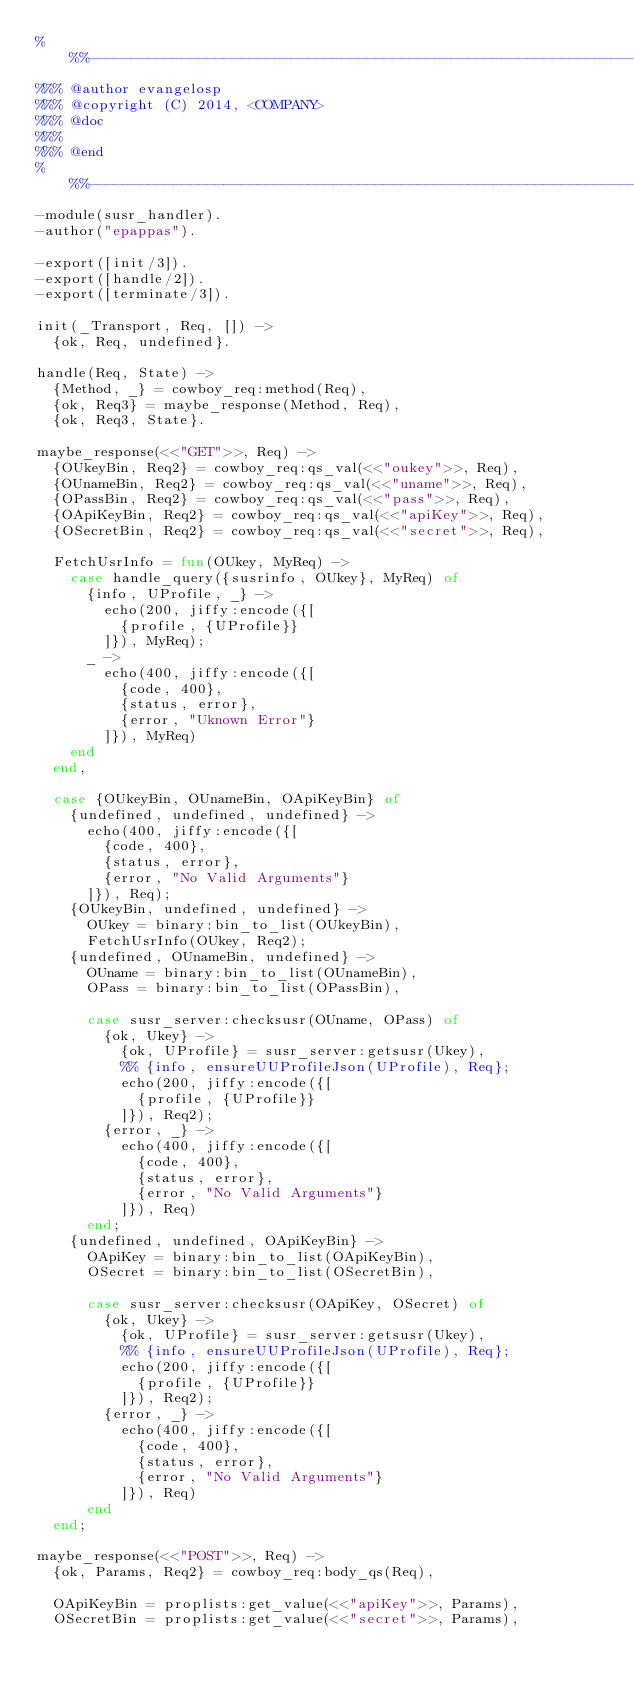Convert code to text. <code><loc_0><loc_0><loc_500><loc_500><_Erlang_>%%%-------------------------------------------------------------------
%%% @author evangelosp
%%% @copyright (C) 2014, <COMPANY>
%%% @doc
%%%
%%% @end
%%%-------------------------------------------------------------------
-module(susr_handler).
-author("epappas").

-export([init/3]).
-export([handle/2]).
-export([terminate/3]).

init(_Transport, Req, []) ->
  {ok, Req, undefined}.

handle(Req, State) ->
  {Method, _} = cowboy_req:method(Req),
  {ok, Req3} = maybe_response(Method, Req),
  {ok, Req3, State}.

maybe_response(<<"GET">>, Req) ->
  {OUkeyBin, Req2} = cowboy_req:qs_val(<<"oukey">>, Req),
  {OUnameBin, Req2} = cowboy_req:qs_val(<<"uname">>, Req),
  {OPassBin, Req2} = cowboy_req:qs_val(<<"pass">>, Req),
  {OApiKeyBin, Req2} = cowboy_req:qs_val(<<"apiKey">>, Req),
  {OSecretBin, Req2} = cowboy_req:qs_val(<<"secret">>, Req),

  FetchUsrInfo = fun(OUkey, MyReq) ->
    case handle_query({susrinfo, OUkey}, MyReq) of
      {info, UProfile, _} ->
        echo(200, jiffy:encode({[
          {profile, {UProfile}}
        ]}), MyReq);
      _ ->
        echo(400, jiffy:encode({[
          {code, 400},
          {status, error},
          {error, "Uknown Error"}
        ]}), MyReq)
    end
  end,

  case {OUkeyBin, OUnameBin, OApiKeyBin} of
    {undefined, undefined, undefined} ->
      echo(400, jiffy:encode({[
        {code, 400},
        {status, error},
        {error, "No Valid Arguments"}
      ]}), Req);
    {OUkeyBin, undefined, undefined} ->
      OUkey = binary:bin_to_list(OUkeyBin),
      FetchUsrInfo(OUkey, Req2);
    {undefined, OUnameBin, undefined} ->
      OUname = binary:bin_to_list(OUnameBin),
      OPass = binary:bin_to_list(OPassBin),

      case susr_server:checksusr(OUname, OPass) of
        {ok, Ukey} ->
          {ok, UProfile} = susr_server:getsusr(Ukey),
          %% {info, ensureUUProfileJson(UProfile), Req};
          echo(200, jiffy:encode({[
            {profile, {UProfile}}
          ]}), Req2);
        {error, _} ->
          echo(400, jiffy:encode({[
            {code, 400},
            {status, error},
            {error, "No Valid Arguments"}
          ]}), Req)
      end;
    {undefined, undefined, OApiKeyBin} ->
      OApiKey = binary:bin_to_list(OApiKeyBin),
      OSecret = binary:bin_to_list(OSecretBin),

      case susr_server:checksusr(OApiKey, OSecret) of
        {ok, Ukey} ->
          {ok, UProfile} = susr_server:getsusr(Ukey),
          %% {info, ensureUUProfileJson(UProfile), Req};
          echo(200, jiffy:encode({[
            {profile, {UProfile}}
          ]}), Req2);
        {error, _} ->
          echo(400, jiffy:encode({[
            {code, 400},
            {status, error},
            {error, "No Valid Arguments"}
          ]}), Req)
      end
  end;

maybe_response(<<"POST">>, Req) ->
  {ok, Params, Req2} = cowboy_req:body_qs(Req),

  OApiKeyBin = proplists:get_value(<<"apiKey">>, Params),
  OSecretBin = proplists:get_value(<<"secret">>, Params),</code> 